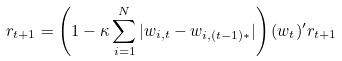<formula> <loc_0><loc_0><loc_500><loc_500>r _ { t + 1 } = \left ( 1 - \kappa \sum _ { i = 1 } ^ { N } { | w _ { i , t } - w _ { i , ( t - 1 ) * } | } \right ) ( w _ { t } ) ^ { \prime } r _ { t + 1 }</formula> 